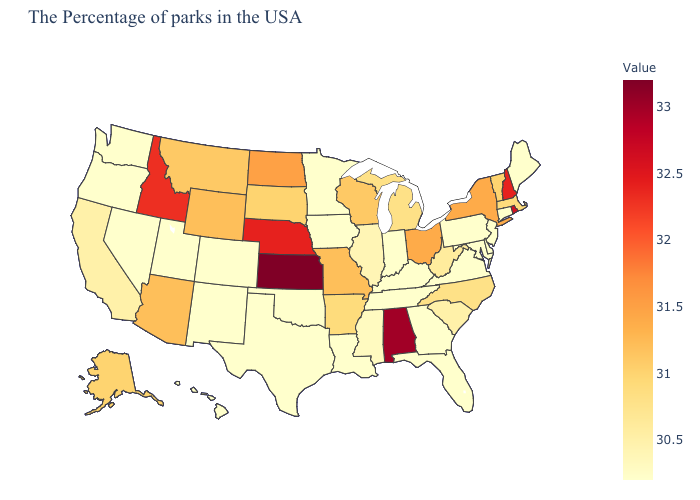Does North Carolina have the lowest value in the USA?
Keep it brief. No. Among the states that border Louisiana , does Arkansas have the highest value?
Write a very short answer. Yes. Does the map have missing data?
Give a very brief answer. No. 